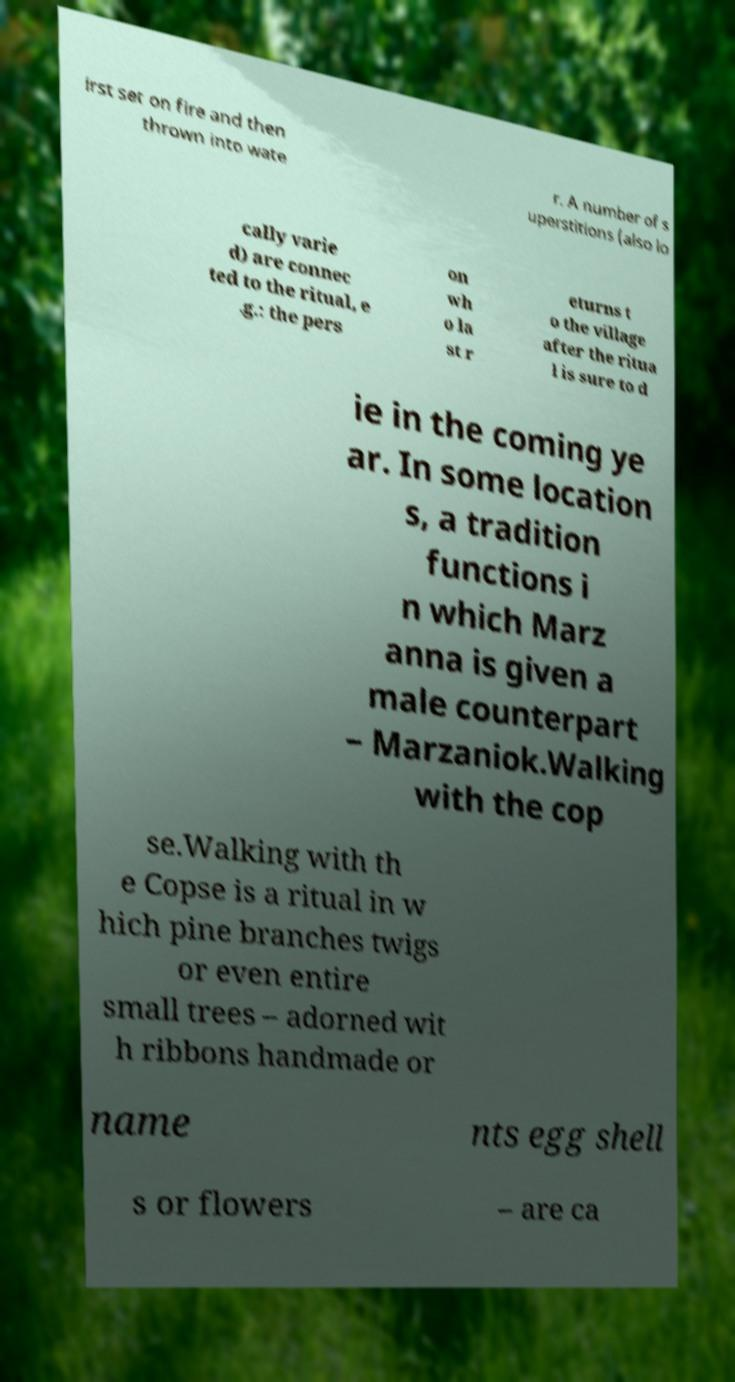Please read and relay the text visible in this image. What does it say? irst set on fire and then thrown into wate r. A number of s uperstitions (also lo cally varie d) are connec ted to the ritual, e .g.: the pers on wh o la st r eturns t o the village after the ritua l is sure to d ie in the coming ye ar. In some location s, a tradition functions i n which Marz anna is given a male counterpart – Marzaniok.Walking with the cop se.Walking with th e Copse is a ritual in w hich pine branches twigs or even entire small trees – adorned wit h ribbons handmade or name nts egg shell s or flowers – are ca 